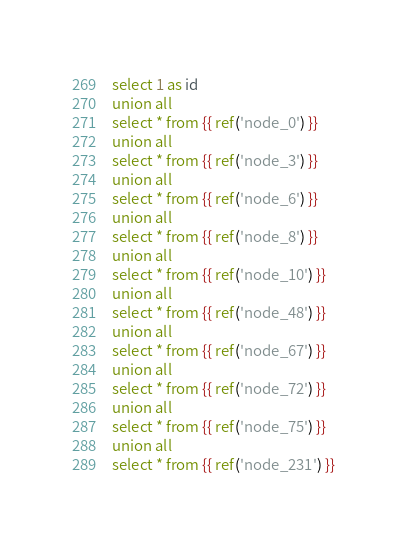Convert code to text. <code><loc_0><loc_0><loc_500><loc_500><_SQL_>select 1 as id
union all
select * from {{ ref('node_0') }}
union all
select * from {{ ref('node_3') }}
union all
select * from {{ ref('node_6') }}
union all
select * from {{ ref('node_8') }}
union all
select * from {{ ref('node_10') }}
union all
select * from {{ ref('node_48') }}
union all
select * from {{ ref('node_67') }}
union all
select * from {{ ref('node_72') }}
union all
select * from {{ ref('node_75') }}
union all
select * from {{ ref('node_231') }}
</code> 